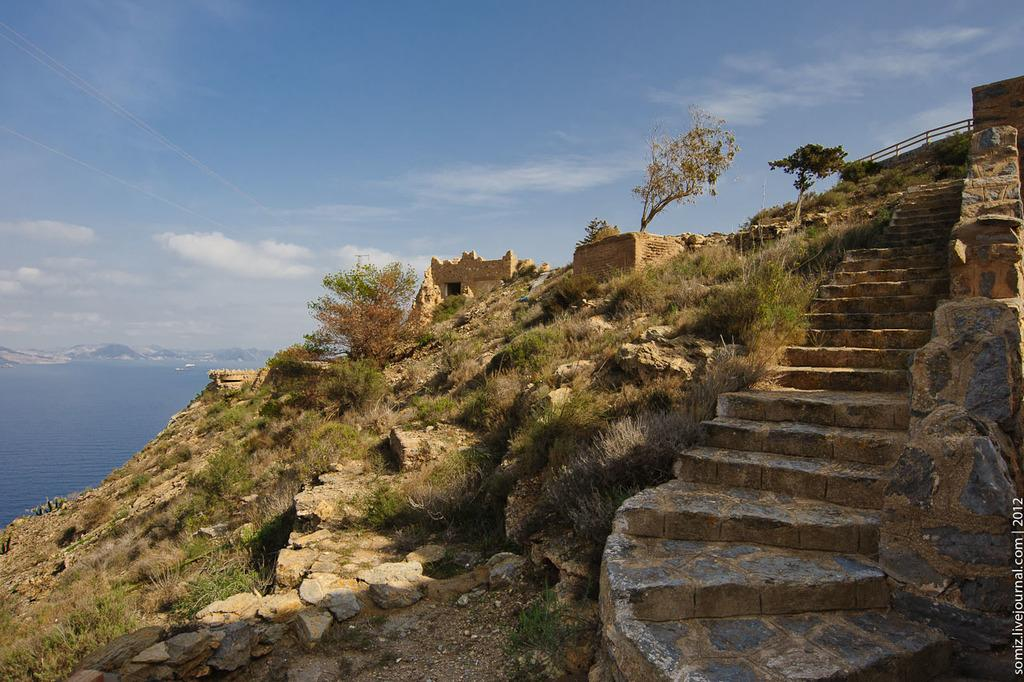What type of structure can be seen in the image? There are stairs in the image. What type of vegetation is present in the image? There are plants, grass, and trees in the image. What other natural elements can be seen in the image? There are rocks and water visible in the image. What is visible in the background of the image? The sky is visible in the background of the image. What type of texture can be seen on the bottle in the image? There is no bottle present in the image. Is there any blood visible in the image? There is no blood visible in the image. 